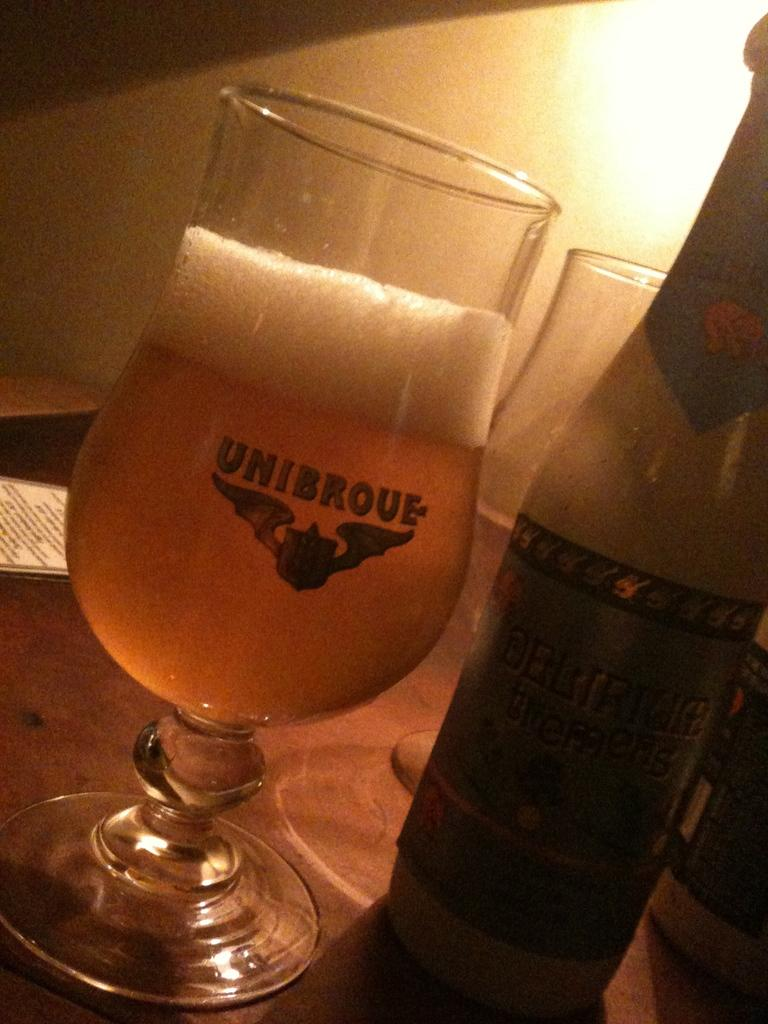What is in the glass that is visible in the image? There is a glass filled with wine in the image. What else can be seen in the image besides the glass of wine? There is a bottle in the image. What can be seen in the background of the image? There is light visible in the background of the image. What type of crow is sitting on the apparel in the image? There is no crow or apparel present in the image. What place is depicted in the image? The image does not depict a specific place; it only shows a glass filled with wine and a bottle. 